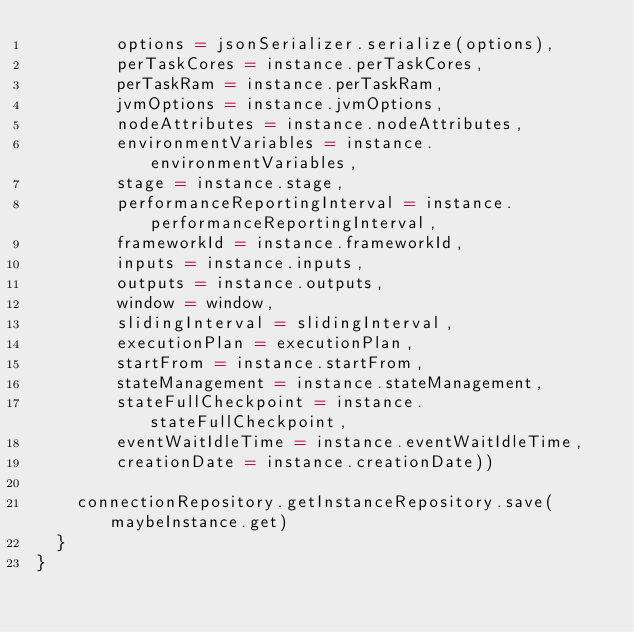<code> <loc_0><loc_0><loc_500><loc_500><_Scala_>        options = jsonSerializer.serialize(options),
        perTaskCores = instance.perTaskCores,
        perTaskRam = instance.perTaskRam,
        jvmOptions = instance.jvmOptions,
        nodeAttributes = instance.nodeAttributes,
        environmentVariables = instance.environmentVariables,
        stage = instance.stage,
        performanceReportingInterval = instance.performanceReportingInterval,
        frameworkId = instance.frameworkId,
        inputs = instance.inputs,
        outputs = instance.outputs,
        window = window,
        slidingInterval = slidingInterval,
        executionPlan = executionPlan,
        startFrom = instance.startFrom,
        stateManagement = instance.stateManagement,
        stateFullCheckpoint = instance.stateFullCheckpoint,
        eventWaitIdleTime = instance.eventWaitIdleTime,
        creationDate = instance.creationDate))

    connectionRepository.getInstanceRepository.save(maybeInstance.get)
  }
}
</code> 